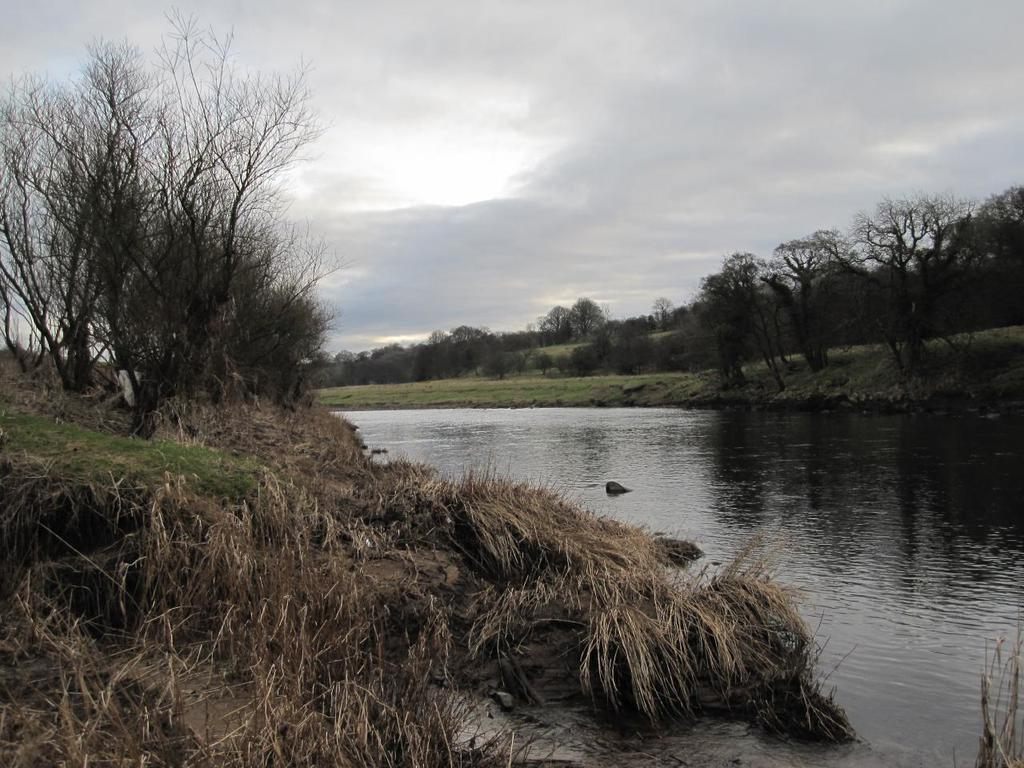What is the primary element visible in the image? There is water in the image. What type of vegetation can be seen in the image? There are trees in the image. What surrounds the water on either side? There is a greenery ground on either side of the water. How would you describe the sky in the image? The sky is cloudy in the image. What type of reaction can be seen happening in the water in the image? There is no reaction happening in the water in the image; it is a still body of water. Is there a station or wheel visible in the image? There is no station or wheel present in the image. 